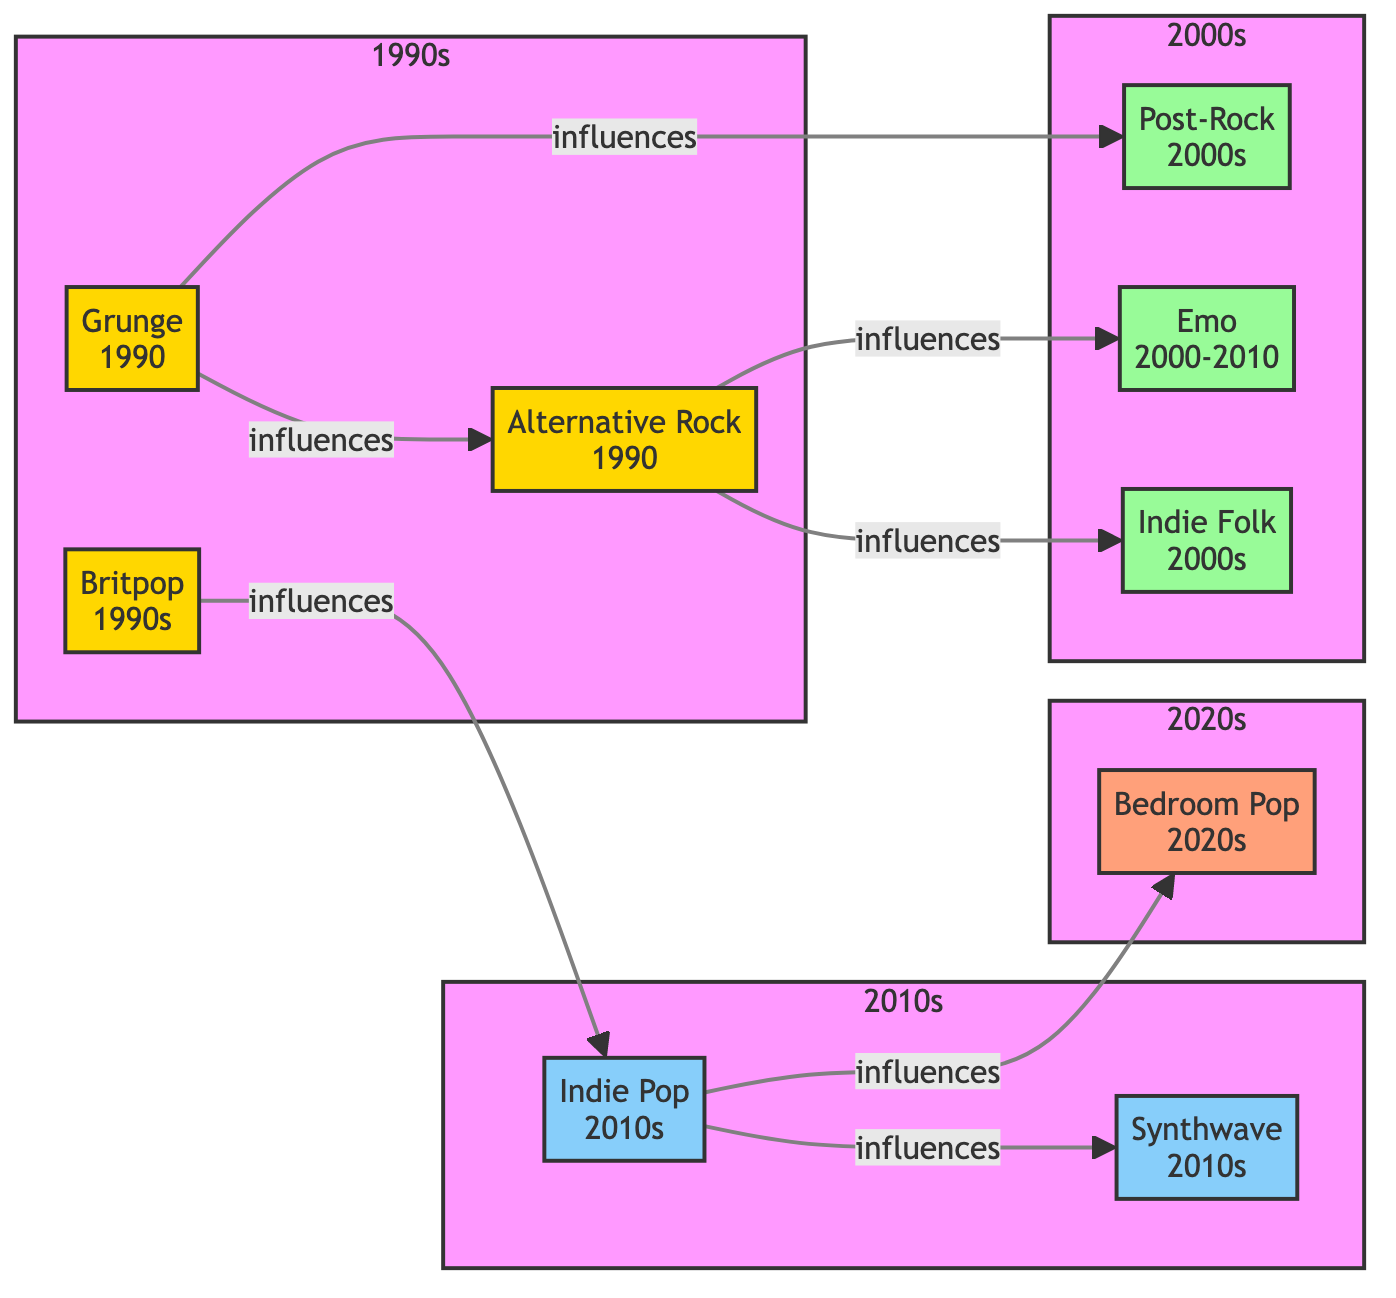What genre was influenced by Grunge? To find the genre influenced by Grunge, look for the node connected to Grunge that has the label indicating influence. The diagram shows that Grunge specifically influences Alternative Rock and Post-Rock.
Answer: Alternative Rock, Post-Rock How many genres are there in the 2010s? Count the number of nodes present in the 2010s subgraph. According to the diagram, there are two genres listed: Indie Pop and Synthwave.
Answer: 2 What influences Indie Pop? Look at the connections leading from Indie Pop to other genres in the diagram. The only direct influence is from Britpop.
Answer: Britpop Which genre originated in the 2000s that relates to the concept of feelings and personal expression? Identify the genre that aligns with feelings. Emo is a genre known for its emotional expression and is categorized under the 2000s.
Answer: Emo Which genre represented the transition to the 2020s? Examine the last genre node in the 2020s subgraph. The node labeled Bedroom Pop is the one that signifies the transition into the 2020s.
Answer: Bedroom Pop What are the three genres that influenced Indie Folk? Identify which genres connect to Indie Folk. The diagram indicates that Indie Folk is influenced by both Alternative Rock and Grunge.
Answer: Alternative Rock, Grunge How many edges are leading out from Indie Pop? Determine how many lines (or arrows) emerge from the Indie Pop node to other genres. Indie Pop has two edges that flow to Synthwave and Bedroom Pop.
Answer: 2 Which genre is a direct influence of Synthwave? Check the genres connected to Synthwave to assess its influences. The diagram shows that there are no connections leading out from Synthwave indicating it does not influence any other genre.
Answer: None Which genre group does Bedroom Pop belong to? Look at the subgraphs to see which group Bedroom Pop falls under. Bedroom Pop is listed in the 2020s subgraph.
Answer: 2020s 